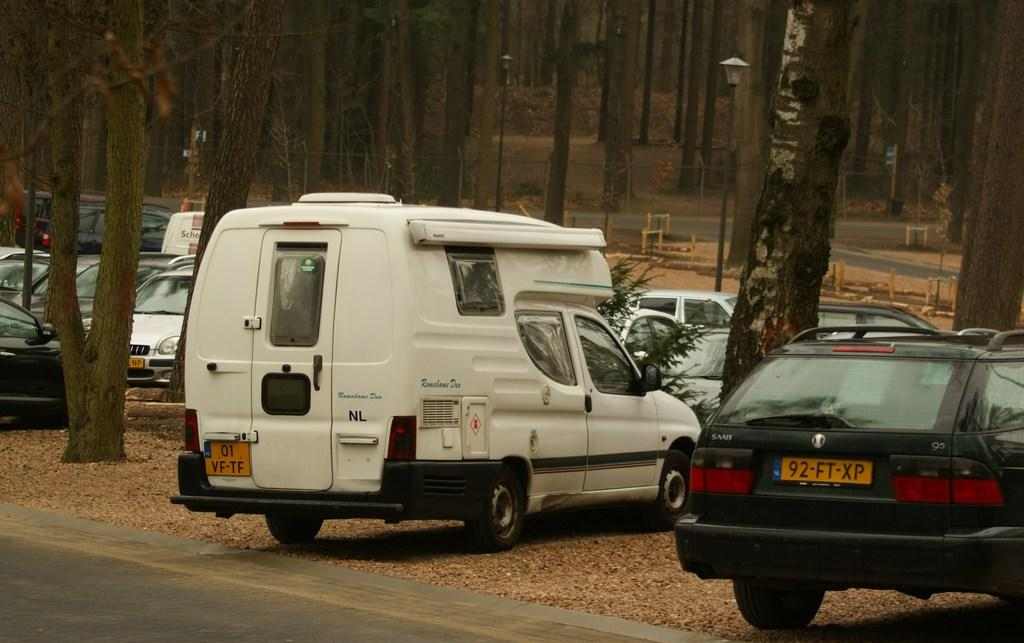What types of objects are present in the image? There are vehicles, wooden structures, street lights, and trees in the image. What is the primary surface in the image? There is a road in the image. Can you describe the lighting in the image? There are street lights present in the image. What type of store can be seen in the image? There is no store present in the image. Can you touch the space in the image? The concept of touching "space" is not applicable in this context, as the image does not depict outer space or any other abstract concept. 